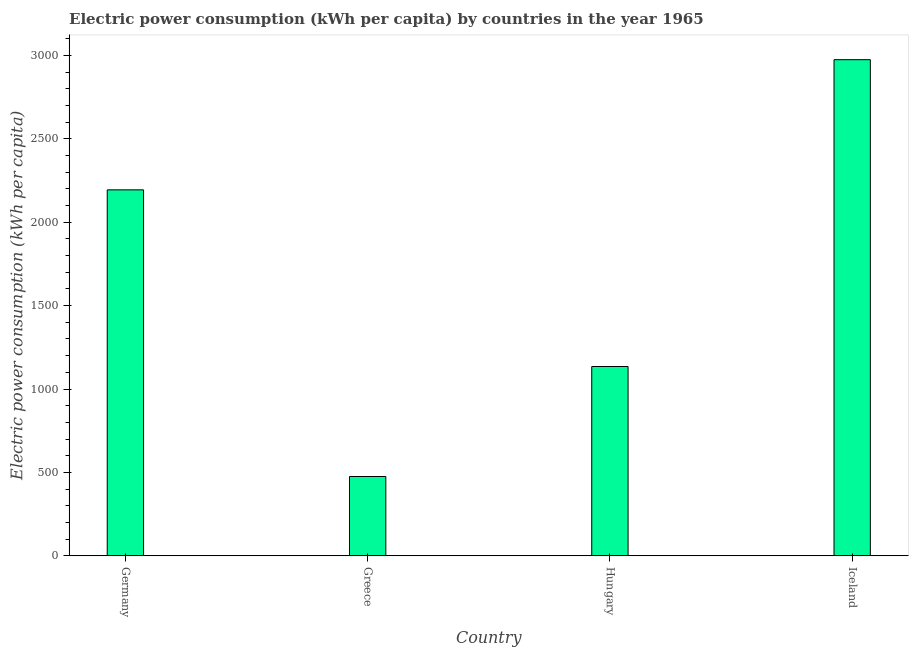What is the title of the graph?
Your answer should be compact. Electric power consumption (kWh per capita) by countries in the year 1965. What is the label or title of the X-axis?
Provide a succinct answer. Country. What is the label or title of the Y-axis?
Ensure brevity in your answer.  Electric power consumption (kWh per capita). What is the electric power consumption in Iceland?
Offer a terse response. 2974.74. Across all countries, what is the maximum electric power consumption?
Your answer should be very brief. 2974.74. Across all countries, what is the minimum electric power consumption?
Give a very brief answer. 475.42. In which country was the electric power consumption maximum?
Make the answer very short. Iceland. In which country was the electric power consumption minimum?
Your answer should be compact. Greece. What is the sum of the electric power consumption?
Your answer should be very brief. 6779.37. What is the difference between the electric power consumption in Germany and Hungary?
Provide a succinct answer. 1059.2. What is the average electric power consumption per country?
Your response must be concise. 1694.84. What is the median electric power consumption?
Offer a terse response. 1664.61. In how many countries, is the electric power consumption greater than 800 kWh per capita?
Offer a very short reply. 3. What is the ratio of the electric power consumption in Germany to that in Iceland?
Provide a succinct answer. 0.74. Is the electric power consumption in Germany less than that in Greece?
Offer a very short reply. No. What is the difference between the highest and the second highest electric power consumption?
Provide a short and direct response. 780.53. Is the sum of the electric power consumption in Germany and Hungary greater than the maximum electric power consumption across all countries?
Offer a terse response. Yes. What is the difference between the highest and the lowest electric power consumption?
Your answer should be compact. 2499.32. How many countries are there in the graph?
Your answer should be very brief. 4. What is the Electric power consumption (kWh per capita) of Germany?
Your answer should be very brief. 2194.21. What is the Electric power consumption (kWh per capita) in Greece?
Offer a very short reply. 475.42. What is the Electric power consumption (kWh per capita) in Hungary?
Your answer should be very brief. 1135.01. What is the Electric power consumption (kWh per capita) of Iceland?
Offer a terse response. 2974.74. What is the difference between the Electric power consumption (kWh per capita) in Germany and Greece?
Make the answer very short. 1718.79. What is the difference between the Electric power consumption (kWh per capita) in Germany and Hungary?
Give a very brief answer. 1059.2. What is the difference between the Electric power consumption (kWh per capita) in Germany and Iceland?
Make the answer very short. -780.53. What is the difference between the Electric power consumption (kWh per capita) in Greece and Hungary?
Your answer should be compact. -659.59. What is the difference between the Electric power consumption (kWh per capita) in Greece and Iceland?
Offer a terse response. -2499.32. What is the difference between the Electric power consumption (kWh per capita) in Hungary and Iceland?
Give a very brief answer. -1839.73. What is the ratio of the Electric power consumption (kWh per capita) in Germany to that in Greece?
Provide a succinct answer. 4.62. What is the ratio of the Electric power consumption (kWh per capita) in Germany to that in Hungary?
Give a very brief answer. 1.93. What is the ratio of the Electric power consumption (kWh per capita) in Germany to that in Iceland?
Your answer should be very brief. 0.74. What is the ratio of the Electric power consumption (kWh per capita) in Greece to that in Hungary?
Your response must be concise. 0.42. What is the ratio of the Electric power consumption (kWh per capita) in Greece to that in Iceland?
Offer a terse response. 0.16. What is the ratio of the Electric power consumption (kWh per capita) in Hungary to that in Iceland?
Provide a succinct answer. 0.38. 